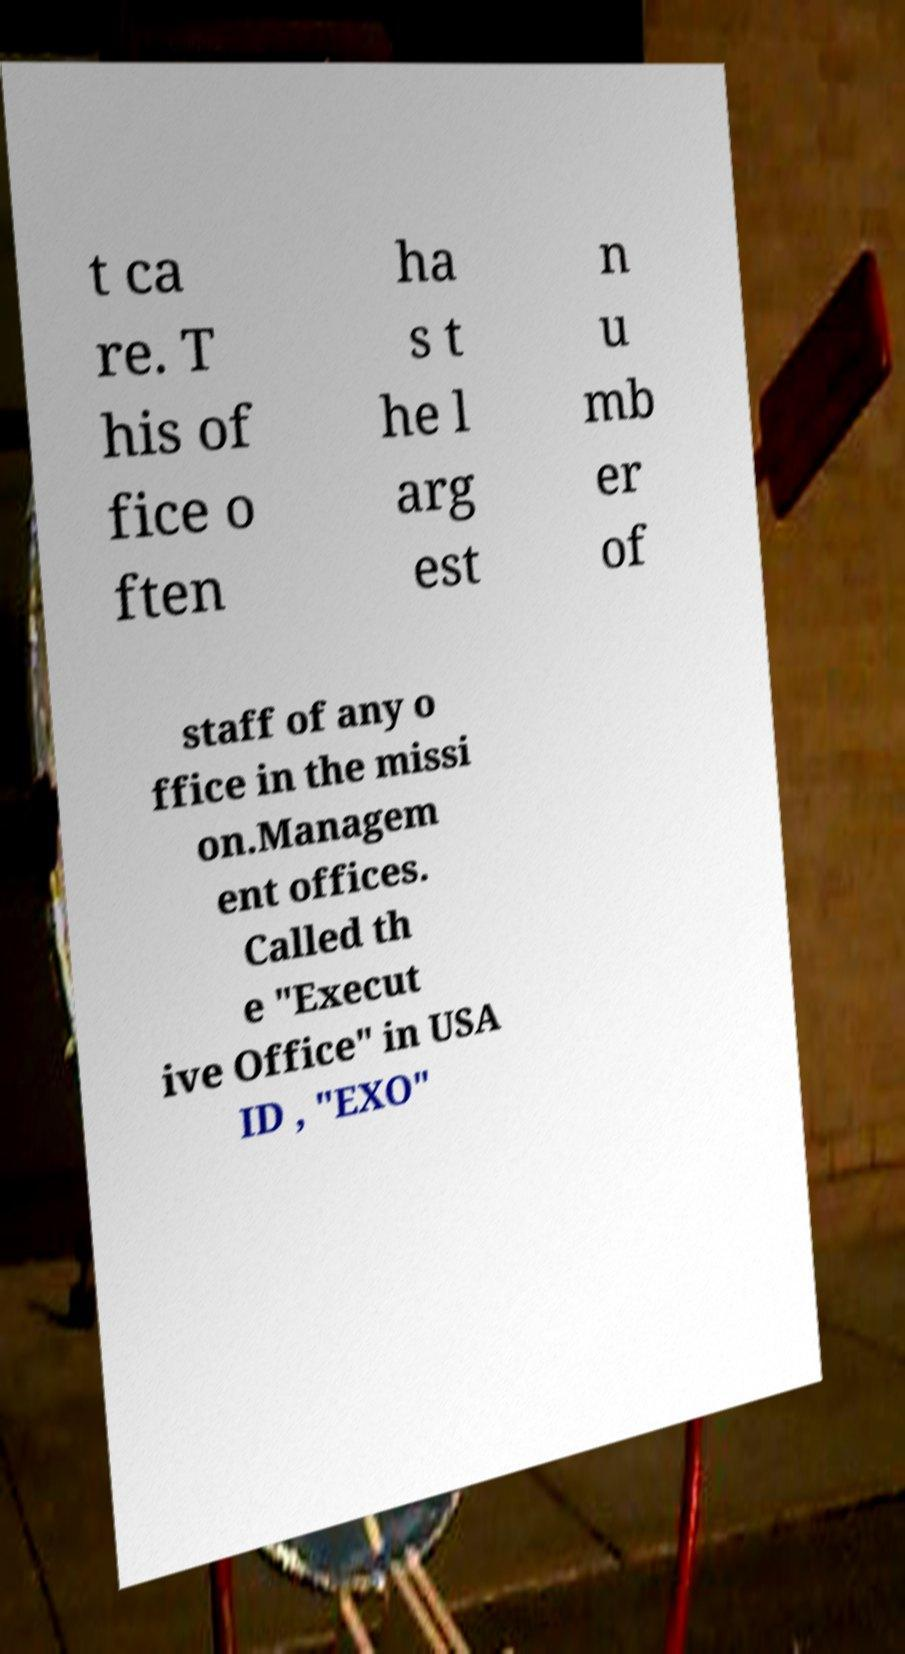I need the written content from this picture converted into text. Can you do that? t ca re. T his of fice o ften ha s t he l arg est n u mb er of staff of any o ffice in the missi on.Managem ent offices. Called th e "Execut ive Office" in USA ID , "EXO" 